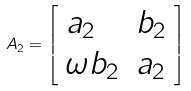Convert formula to latex. <formula><loc_0><loc_0><loc_500><loc_500>A _ { 2 } = { \left [ \begin{array} { l l } { a _ { 2 } } & { b _ { 2 } } \\ { \omega b _ { 2 } } & { a _ { 2 } } \end{array} \right ] }</formula> 